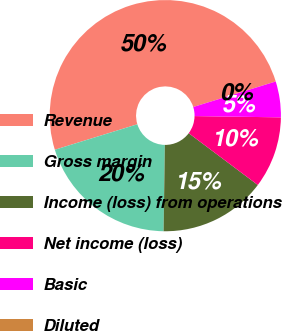<chart> <loc_0><loc_0><loc_500><loc_500><pie_chart><fcel>Revenue<fcel>Gross margin<fcel>Income (loss) from operations<fcel>Net income (loss)<fcel>Basic<fcel>Diluted<nl><fcel>49.98%<fcel>20.0%<fcel>15.0%<fcel>10.0%<fcel>5.01%<fcel>0.01%<nl></chart> 